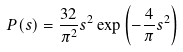Convert formula to latex. <formula><loc_0><loc_0><loc_500><loc_500>P ( s ) = \frac { 3 2 } { \pi ^ { 2 } } s ^ { 2 } \exp { \left ( - \frac { 4 } { \pi } s ^ { 2 } \right ) }</formula> 